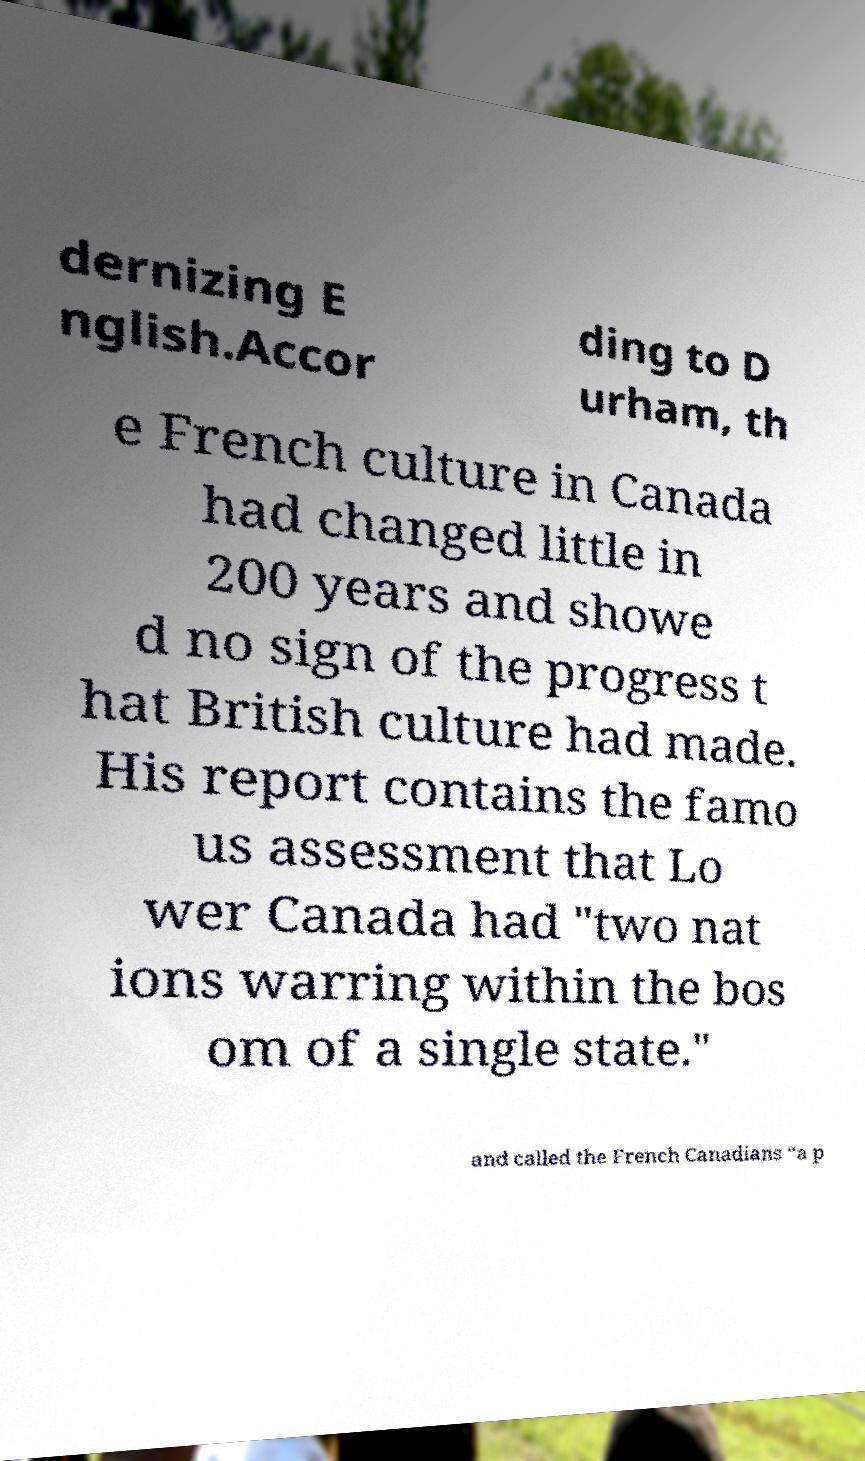Could you assist in decoding the text presented in this image and type it out clearly? dernizing E nglish.Accor ding to D urham, th e French culture in Canada had changed little in 200 years and showe d no sign of the progress t hat British culture had made. His report contains the famo us assessment that Lo wer Canada had "two nat ions warring within the bos om of a single state." and called the French Canadians “a p 